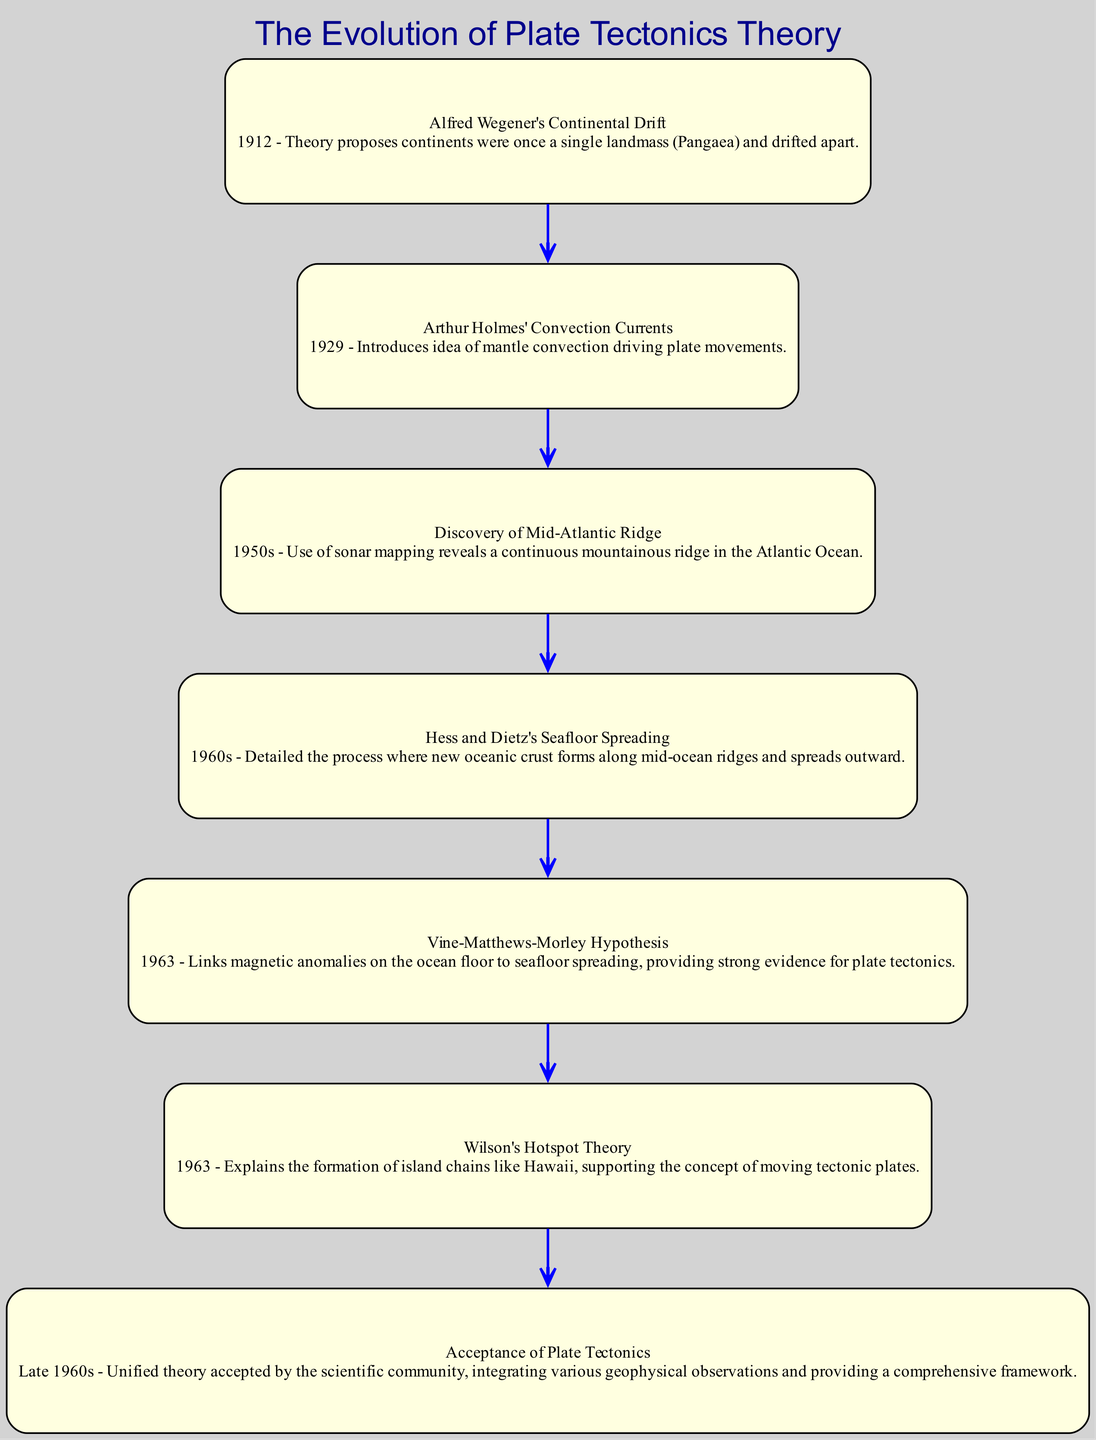What was Wegener's theory called? The diagram states that Alfred Wegener's theory is called "Continental Drift," which was proposed in 1912, indicating that it involves the idea that continents were once a single landmass called Pangaea.
Answer: Continental Drift How many nodes are in the diagram? The diagram lists seven distinct nodes that represent critical developments in the evolution of plate tectonics theory. By counting each unique node listed, we confirm there are seven.
Answer: 7 What follows the discovery of the Mid-Atlantic Ridge? According to the transitions in the diagram, the node that follows the discovery of the Mid-Atlantic Ridge is "Hess and Dietz's Seafloor Spreading." This can be concluded by tracking the flow from the mid-Atlantic ridge to the next event.
Answer: Hess and Dietz's Seafloor Spreading What year did the Vine-Matthews-Morley hypothesis emerge? The diagram indicates that the Vine-Matthews-Morley hypothesis was introduced in 1963, which can be easily seen adjacent to that node in the flow of the pathway.
Answer: 1963 What is the significance of Wilson's Hotspot Theory? The diagram highlights that Wilson's Hotspot Theory explains the formation of island chains like Hawaii, indicating its role in supporting the concept of moving tectonic plates. This significance is derived from the description provided in the node.
Answer: Formation of island chains What is the final event in the evolution of plate tectonics theory? By analyzing the transitions in the diagram, the final event that represents the evolution of plate tectonics theory is the "Acceptance of Plate Tectonics," which appears at the end of the pathway as the final node, illustrating the culmination of the theory's acceptance.
Answer: Acceptance of Plate Tectonics What relationship exists between Holmes' Convection Currents and the Mid-Atlantic Ridge? The diagram suggests a direct relationship by showing a transition from "Arthur Holmes' Convection Currents" to the "Discovery of Mid-Atlantic Ridge," indicating that the understanding of mantle convection contributed to the discoveries in plate tectonics through the framework of convection processes.
Answer: Convection contributing to discoveries 